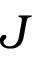Convert formula to latex. <formula><loc_0><loc_0><loc_500><loc_500>J</formula> 